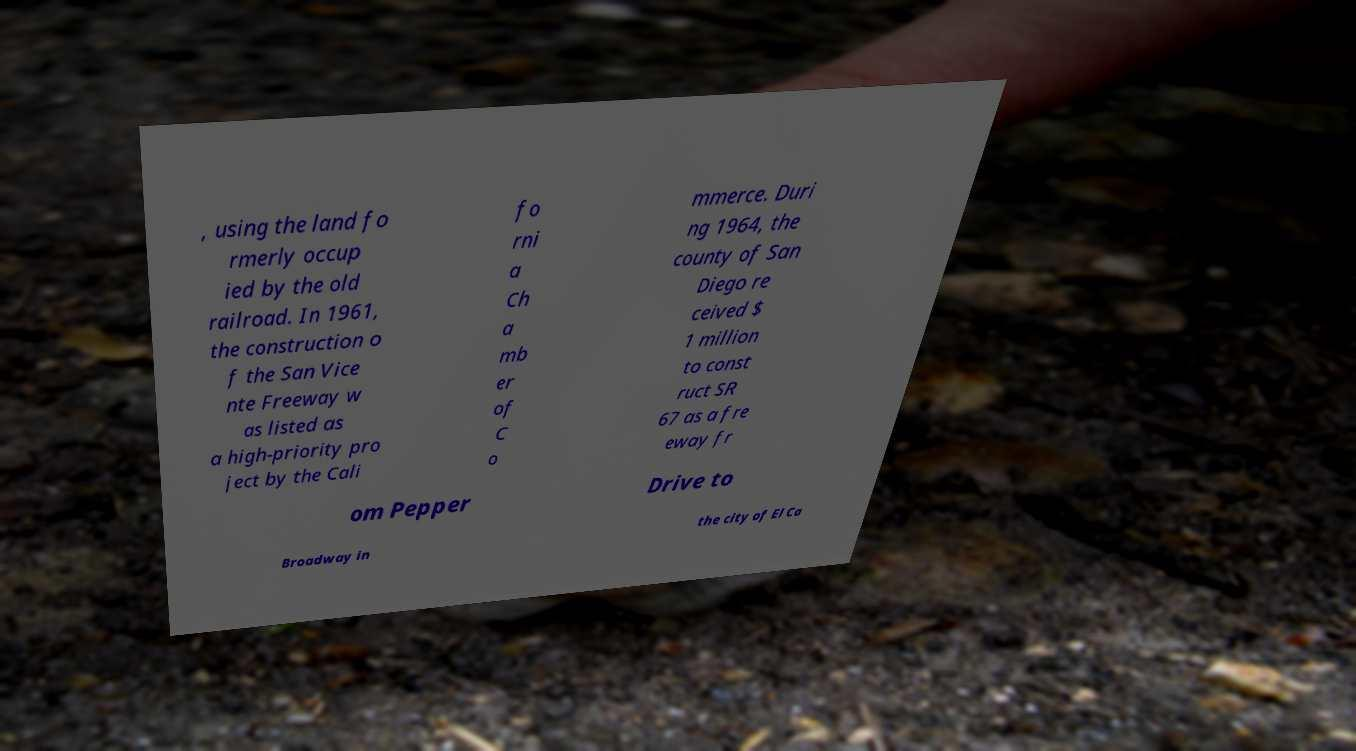For documentation purposes, I need the text within this image transcribed. Could you provide that? , using the land fo rmerly occup ied by the old railroad. In 1961, the construction o f the San Vice nte Freeway w as listed as a high-priority pro ject by the Cali fo rni a Ch a mb er of C o mmerce. Duri ng 1964, the county of San Diego re ceived $ 1 million to const ruct SR 67 as a fre eway fr om Pepper Drive to Broadway in the city of El Ca 